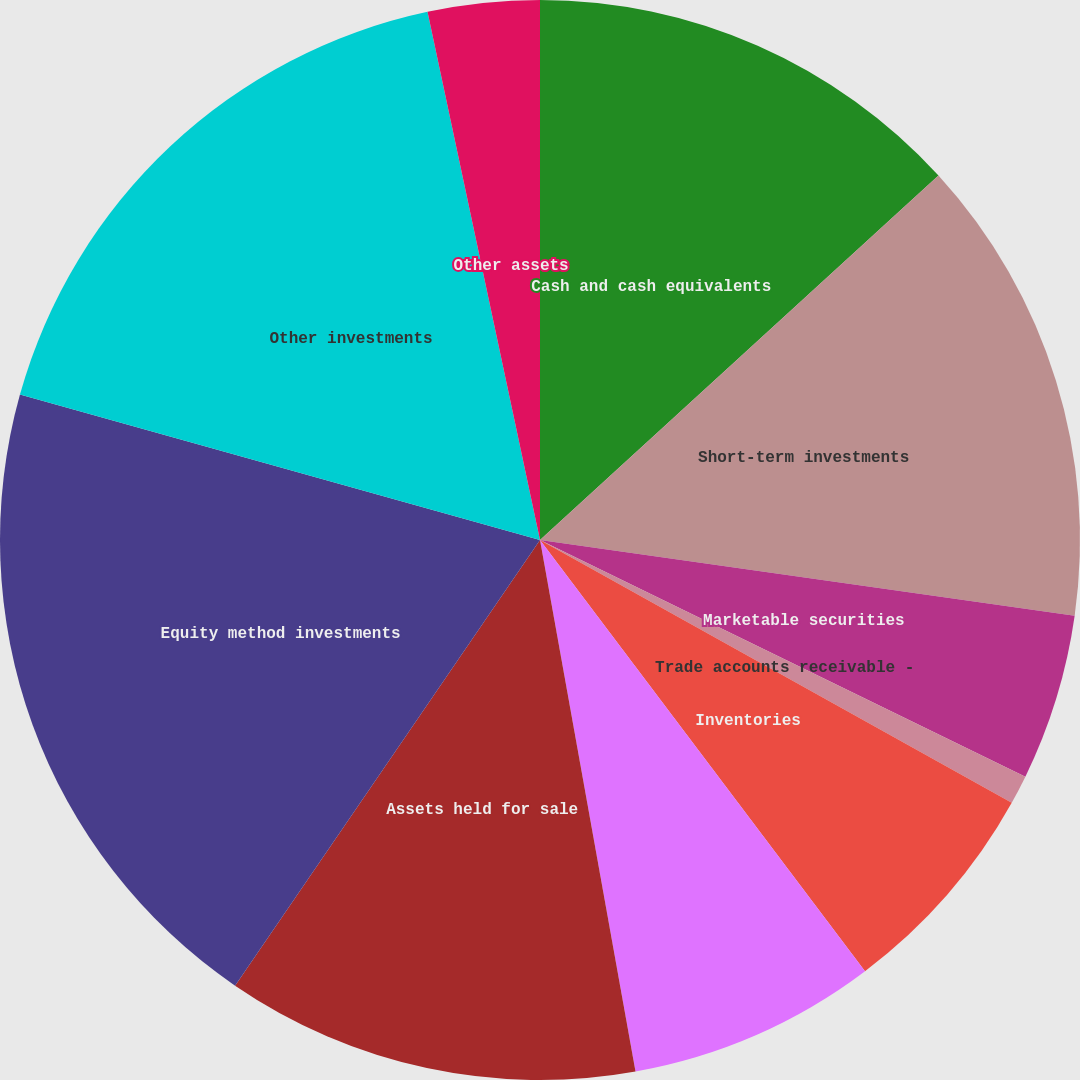Convert chart. <chart><loc_0><loc_0><loc_500><loc_500><pie_chart><fcel>Cash and cash equivalents<fcel>Short-term investments<fcel>Marketable securities<fcel>Trade accounts receivable -<fcel>Inventories<fcel>Prepaid expenses and other<fcel>Assets held for sale<fcel>Equity method investments<fcel>Other investments<fcel>Other assets<nl><fcel>13.21%<fcel>14.03%<fcel>4.98%<fcel>0.87%<fcel>6.63%<fcel>7.45%<fcel>12.38%<fcel>19.79%<fcel>17.32%<fcel>3.34%<nl></chart> 